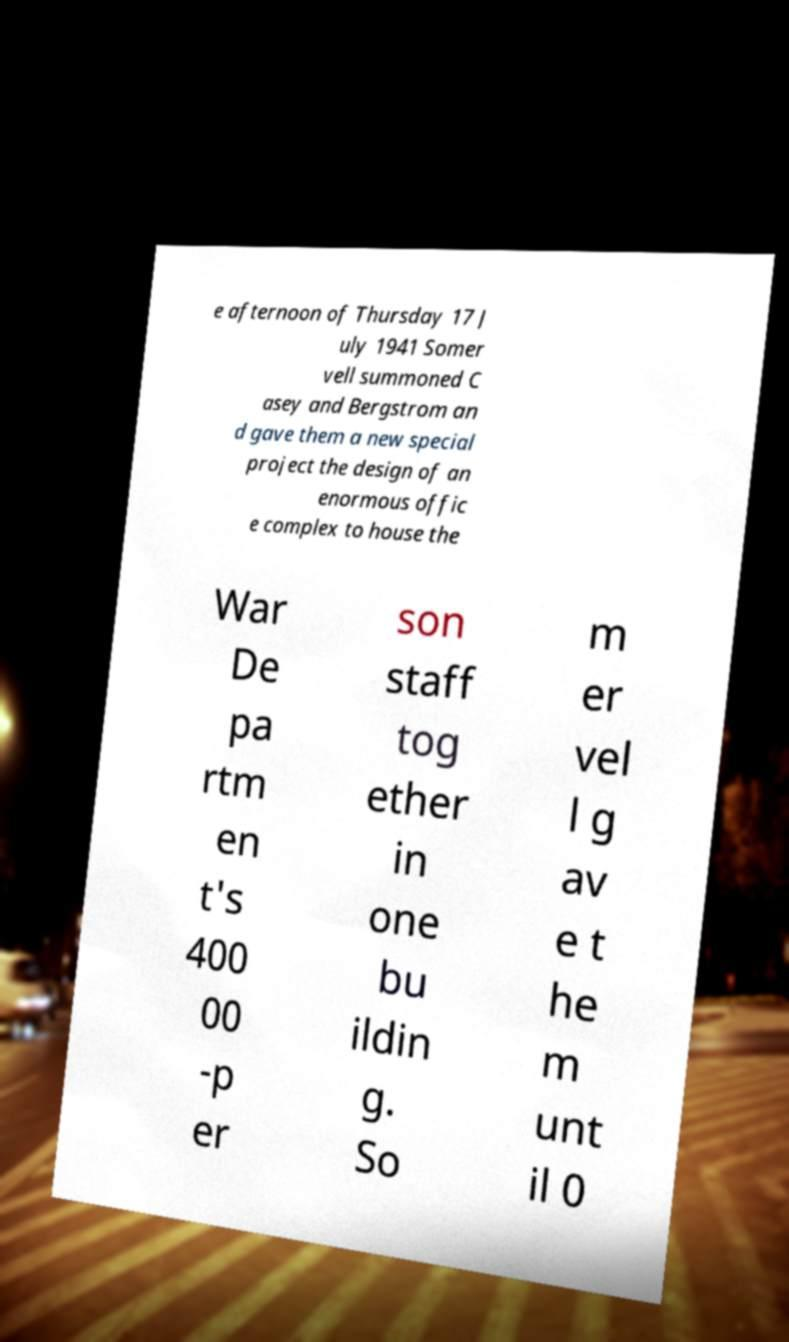There's text embedded in this image that I need extracted. Can you transcribe it verbatim? e afternoon of Thursday 17 J uly 1941 Somer vell summoned C asey and Bergstrom an d gave them a new special project the design of an enormous offic e complex to house the War De pa rtm en t's 400 00 -p er son staff tog ether in one bu ildin g. So m er vel l g av e t he m unt il 0 